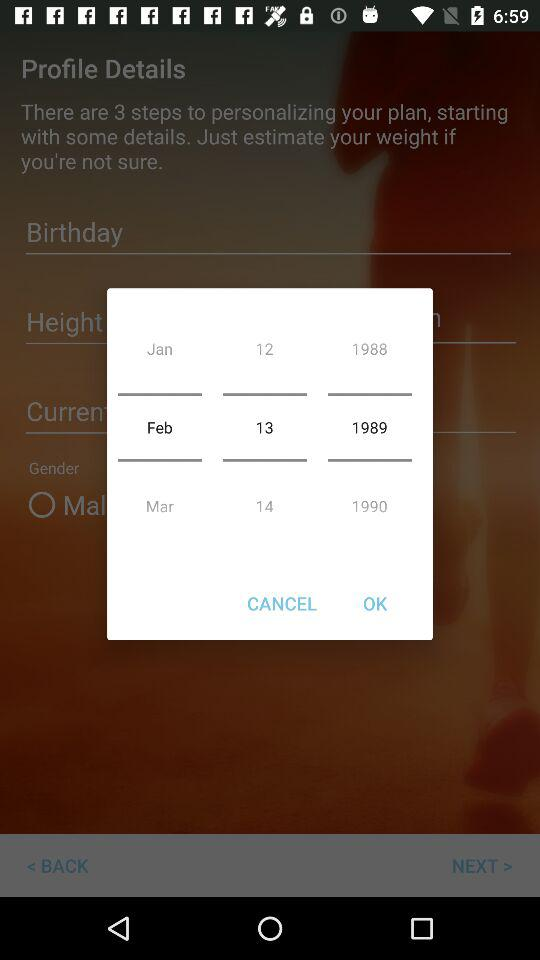How many years are represented by the text on the screen?
Answer the question using a single word or phrase. 3 